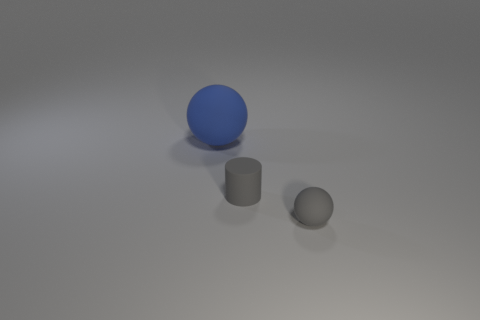What is the shape of the object that is behind the gray sphere and in front of the blue object?
Offer a terse response. Cylinder. Are there any cylinders made of the same material as the tiny gray sphere?
Provide a short and direct response. Yes. There is a thing that is the same color as the matte cylinder; what is its material?
Your response must be concise. Rubber. Does the ball in front of the blue thing have the same material as the small thing that is on the left side of the tiny ball?
Your response must be concise. Yes. Are there more big cyan metal spheres than tiny gray rubber cylinders?
Your answer should be very brief. No. What color is the rubber ball that is on the right side of the blue object that is to the left of the sphere in front of the large rubber object?
Ensure brevity in your answer.  Gray. Is the color of the rubber sphere to the right of the big blue object the same as the small thing that is to the left of the small gray ball?
Your response must be concise. Yes. How many balls are to the left of the small matte object in front of the gray cylinder?
Offer a terse response. 1. Are any big blue rubber things visible?
Your answer should be very brief. Yes. How many other things are the same color as the small matte cylinder?
Keep it short and to the point. 1. 